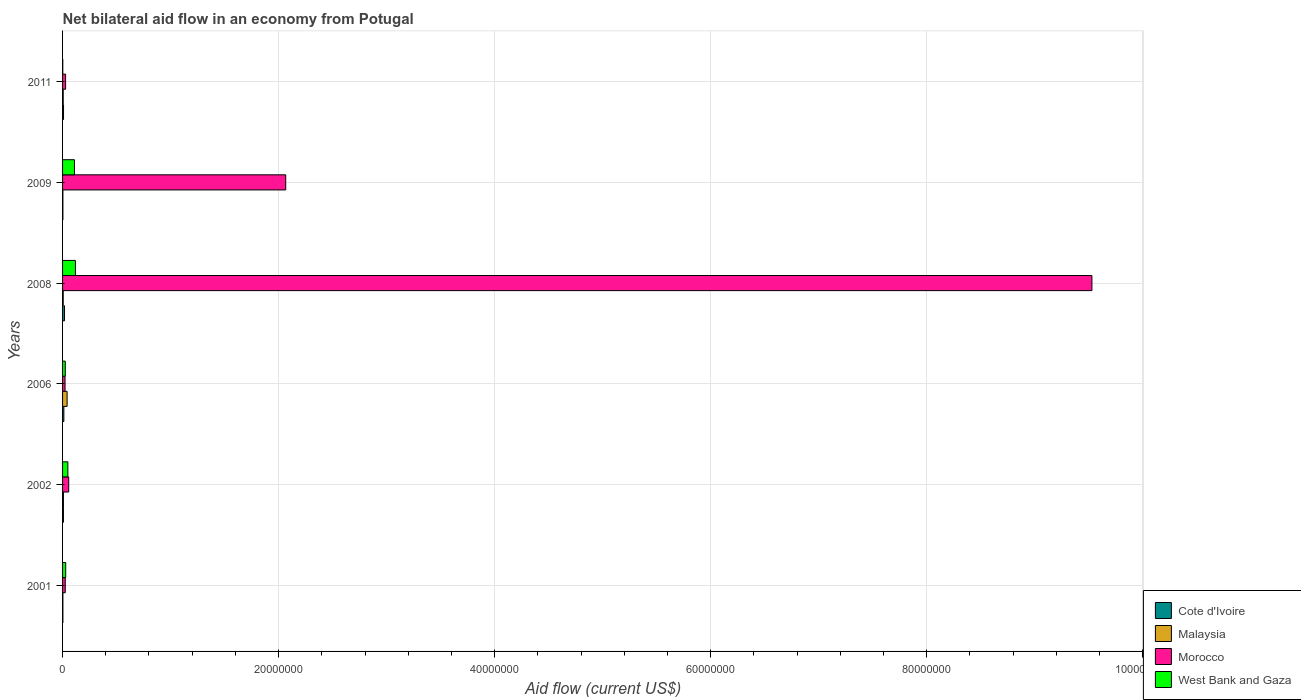How many different coloured bars are there?
Give a very brief answer. 4. Are the number of bars on each tick of the Y-axis equal?
Your answer should be compact. Yes. How many bars are there on the 5th tick from the bottom?
Offer a very short reply. 4. Across all years, what is the maximum net bilateral aid flow in Cote d'Ivoire?
Your response must be concise. 1.80e+05. In which year was the net bilateral aid flow in Malaysia maximum?
Offer a terse response. 2006. What is the total net bilateral aid flow in Morocco in the graph?
Ensure brevity in your answer.  1.17e+08. What is the difference between the net bilateral aid flow in Morocco in 2008 and that in 2009?
Your answer should be very brief. 7.46e+07. What is the difference between the net bilateral aid flow in Cote d'Ivoire in 2006 and the net bilateral aid flow in Morocco in 2009?
Ensure brevity in your answer.  -2.05e+07. What is the average net bilateral aid flow in Cote d'Ivoire per year?
Your response must be concise. 8.83e+04. What is the ratio of the net bilateral aid flow in Cote d'Ivoire in 2002 to that in 2008?
Ensure brevity in your answer.  0.44. Is the difference between the net bilateral aid flow in West Bank and Gaza in 2006 and 2011 greater than the difference between the net bilateral aid flow in Malaysia in 2006 and 2011?
Provide a short and direct response. No. What is the difference between the highest and the second highest net bilateral aid flow in Cote d'Ivoire?
Keep it short and to the point. 6.00e+04. In how many years, is the net bilateral aid flow in Cote d'Ivoire greater than the average net bilateral aid flow in Cote d'Ivoire taken over all years?
Provide a succinct answer. 3. Is it the case that in every year, the sum of the net bilateral aid flow in Morocco and net bilateral aid flow in West Bank and Gaza is greater than the sum of net bilateral aid flow in Cote d'Ivoire and net bilateral aid flow in Malaysia?
Your answer should be very brief. No. What does the 1st bar from the top in 2008 represents?
Offer a terse response. West Bank and Gaza. What does the 4th bar from the bottom in 2011 represents?
Provide a succinct answer. West Bank and Gaza. How many bars are there?
Provide a short and direct response. 24. Are all the bars in the graph horizontal?
Offer a terse response. Yes. What is the difference between two consecutive major ticks on the X-axis?
Offer a very short reply. 2.00e+07. Are the values on the major ticks of X-axis written in scientific E-notation?
Ensure brevity in your answer.  No. How many legend labels are there?
Your answer should be compact. 4. What is the title of the graph?
Offer a very short reply. Net bilateral aid flow in an economy from Potugal. Does "Guyana" appear as one of the legend labels in the graph?
Your answer should be very brief. No. What is the Aid flow (current US$) in Malaysia in 2001?
Give a very brief answer. 3.00e+04. What is the Aid flow (current US$) in West Bank and Gaza in 2001?
Your answer should be very brief. 2.90e+05. What is the Aid flow (current US$) in Morocco in 2002?
Provide a short and direct response. 5.70e+05. What is the Aid flow (current US$) in West Bank and Gaza in 2002?
Your answer should be compact. 4.90e+05. What is the Aid flow (current US$) in Cote d'Ivoire in 2006?
Give a very brief answer. 1.20e+05. What is the Aid flow (current US$) of Malaysia in 2006?
Offer a terse response. 4.20e+05. What is the Aid flow (current US$) of Morocco in 2006?
Give a very brief answer. 2.30e+05. What is the Aid flow (current US$) in Malaysia in 2008?
Make the answer very short. 6.00e+04. What is the Aid flow (current US$) in Morocco in 2008?
Give a very brief answer. 9.53e+07. What is the Aid flow (current US$) of West Bank and Gaza in 2008?
Provide a short and direct response. 1.19e+06. What is the Aid flow (current US$) in Cote d'Ivoire in 2009?
Offer a very short reply. 3.00e+04. What is the Aid flow (current US$) in Malaysia in 2009?
Offer a terse response. 3.00e+04. What is the Aid flow (current US$) of Morocco in 2009?
Your answer should be very brief. 2.07e+07. What is the Aid flow (current US$) in West Bank and Gaza in 2009?
Make the answer very short. 1.10e+06. Across all years, what is the maximum Aid flow (current US$) in Morocco?
Your answer should be very brief. 9.53e+07. Across all years, what is the maximum Aid flow (current US$) in West Bank and Gaza?
Offer a very short reply. 1.19e+06. Across all years, what is the minimum Aid flow (current US$) in Cote d'Ivoire?
Provide a short and direct response. 3.00e+04. Across all years, what is the minimum Aid flow (current US$) of Malaysia?
Provide a succinct answer. 3.00e+04. Across all years, what is the minimum Aid flow (current US$) in Morocco?
Provide a short and direct response. 2.30e+05. Across all years, what is the minimum Aid flow (current US$) of West Bank and Gaza?
Make the answer very short. 2.00e+04. What is the total Aid flow (current US$) of Cote d'Ivoire in the graph?
Keep it short and to the point. 5.30e+05. What is the total Aid flow (current US$) in Malaysia in the graph?
Keep it short and to the point. 6.80e+05. What is the total Aid flow (current US$) in Morocco in the graph?
Your answer should be compact. 1.17e+08. What is the total Aid flow (current US$) in West Bank and Gaza in the graph?
Offer a terse response. 3.34e+06. What is the difference between the Aid flow (current US$) of Cote d'Ivoire in 2001 and that in 2002?
Provide a short and direct response. -5.00e+04. What is the difference between the Aid flow (current US$) of Morocco in 2001 and that in 2002?
Ensure brevity in your answer.  -3.20e+05. What is the difference between the Aid flow (current US$) of Malaysia in 2001 and that in 2006?
Give a very brief answer. -3.90e+05. What is the difference between the Aid flow (current US$) of Morocco in 2001 and that in 2006?
Provide a succinct answer. 2.00e+04. What is the difference between the Aid flow (current US$) in West Bank and Gaza in 2001 and that in 2006?
Ensure brevity in your answer.  4.00e+04. What is the difference between the Aid flow (current US$) of Cote d'Ivoire in 2001 and that in 2008?
Make the answer very short. -1.50e+05. What is the difference between the Aid flow (current US$) of Malaysia in 2001 and that in 2008?
Make the answer very short. -3.00e+04. What is the difference between the Aid flow (current US$) in Morocco in 2001 and that in 2008?
Keep it short and to the point. -9.50e+07. What is the difference between the Aid flow (current US$) of West Bank and Gaza in 2001 and that in 2008?
Your answer should be compact. -9.00e+05. What is the difference between the Aid flow (current US$) of Malaysia in 2001 and that in 2009?
Give a very brief answer. 0. What is the difference between the Aid flow (current US$) of Morocco in 2001 and that in 2009?
Give a very brief answer. -2.04e+07. What is the difference between the Aid flow (current US$) of West Bank and Gaza in 2001 and that in 2009?
Your answer should be very brief. -8.10e+05. What is the difference between the Aid flow (current US$) of Morocco in 2001 and that in 2011?
Provide a succinct answer. -3.00e+04. What is the difference between the Aid flow (current US$) in West Bank and Gaza in 2001 and that in 2011?
Offer a terse response. 2.70e+05. What is the difference between the Aid flow (current US$) in West Bank and Gaza in 2002 and that in 2006?
Make the answer very short. 2.40e+05. What is the difference between the Aid flow (current US$) of Cote d'Ivoire in 2002 and that in 2008?
Your answer should be very brief. -1.00e+05. What is the difference between the Aid flow (current US$) of Malaysia in 2002 and that in 2008?
Offer a terse response. 2.00e+04. What is the difference between the Aid flow (current US$) in Morocco in 2002 and that in 2008?
Offer a terse response. -9.47e+07. What is the difference between the Aid flow (current US$) in West Bank and Gaza in 2002 and that in 2008?
Provide a short and direct response. -7.00e+05. What is the difference between the Aid flow (current US$) of Cote d'Ivoire in 2002 and that in 2009?
Provide a succinct answer. 5.00e+04. What is the difference between the Aid flow (current US$) of Malaysia in 2002 and that in 2009?
Your answer should be very brief. 5.00e+04. What is the difference between the Aid flow (current US$) in Morocco in 2002 and that in 2009?
Keep it short and to the point. -2.01e+07. What is the difference between the Aid flow (current US$) of West Bank and Gaza in 2002 and that in 2009?
Offer a very short reply. -6.10e+05. What is the difference between the Aid flow (current US$) of Morocco in 2002 and that in 2011?
Give a very brief answer. 2.90e+05. What is the difference between the Aid flow (current US$) of Morocco in 2006 and that in 2008?
Your response must be concise. -9.51e+07. What is the difference between the Aid flow (current US$) in West Bank and Gaza in 2006 and that in 2008?
Ensure brevity in your answer.  -9.40e+05. What is the difference between the Aid flow (current US$) in Cote d'Ivoire in 2006 and that in 2009?
Give a very brief answer. 9.00e+04. What is the difference between the Aid flow (current US$) in Malaysia in 2006 and that in 2009?
Provide a succinct answer. 3.90e+05. What is the difference between the Aid flow (current US$) in Morocco in 2006 and that in 2009?
Your answer should be compact. -2.04e+07. What is the difference between the Aid flow (current US$) of West Bank and Gaza in 2006 and that in 2009?
Make the answer very short. -8.50e+05. What is the difference between the Aid flow (current US$) of Morocco in 2006 and that in 2011?
Provide a short and direct response. -5.00e+04. What is the difference between the Aid flow (current US$) in Cote d'Ivoire in 2008 and that in 2009?
Offer a very short reply. 1.50e+05. What is the difference between the Aid flow (current US$) of Malaysia in 2008 and that in 2009?
Your answer should be compact. 3.00e+04. What is the difference between the Aid flow (current US$) in Morocco in 2008 and that in 2009?
Provide a succinct answer. 7.46e+07. What is the difference between the Aid flow (current US$) in West Bank and Gaza in 2008 and that in 2009?
Offer a terse response. 9.00e+04. What is the difference between the Aid flow (current US$) in Malaysia in 2008 and that in 2011?
Provide a short and direct response. 0. What is the difference between the Aid flow (current US$) of Morocco in 2008 and that in 2011?
Your answer should be very brief. 9.50e+07. What is the difference between the Aid flow (current US$) of West Bank and Gaza in 2008 and that in 2011?
Your answer should be compact. 1.17e+06. What is the difference between the Aid flow (current US$) in Morocco in 2009 and that in 2011?
Make the answer very short. 2.04e+07. What is the difference between the Aid flow (current US$) of West Bank and Gaza in 2009 and that in 2011?
Keep it short and to the point. 1.08e+06. What is the difference between the Aid flow (current US$) of Cote d'Ivoire in 2001 and the Aid flow (current US$) of Malaysia in 2002?
Your response must be concise. -5.00e+04. What is the difference between the Aid flow (current US$) in Cote d'Ivoire in 2001 and the Aid flow (current US$) in Morocco in 2002?
Your answer should be very brief. -5.40e+05. What is the difference between the Aid flow (current US$) of Cote d'Ivoire in 2001 and the Aid flow (current US$) of West Bank and Gaza in 2002?
Provide a short and direct response. -4.60e+05. What is the difference between the Aid flow (current US$) in Malaysia in 2001 and the Aid flow (current US$) in Morocco in 2002?
Your response must be concise. -5.40e+05. What is the difference between the Aid flow (current US$) in Malaysia in 2001 and the Aid flow (current US$) in West Bank and Gaza in 2002?
Keep it short and to the point. -4.60e+05. What is the difference between the Aid flow (current US$) of Cote d'Ivoire in 2001 and the Aid flow (current US$) of Malaysia in 2006?
Keep it short and to the point. -3.90e+05. What is the difference between the Aid flow (current US$) in Cote d'Ivoire in 2001 and the Aid flow (current US$) in Morocco in 2006?
Your response must be concise. -2.00e+05. What is the difference between the Aid flow (current US$) in Cote d'Ivoire in 2001 and the Aid flow (current US$) in Morocco in 2008?
Keep it short and to the point. -9.53e+07. What is the difference between the Aid flow (current US$) of Cote d'Ivoire in 2001 and the Aid flow (current US$) of West Bank and Gaza in 2008?
Give a very brief answer. -1.16e+06. What is the difference between the Aid flow (current US$) of Malaysia in 2001 and the Aid flow (current US$) of Morocco in 2008?
Make the answer very short. -9.53e+07. What is the difference between the Aid flow (current US$) in Malaysia in 2001 and the Aid flow (current US$) in West Bank and Gaza in 2008?
Give a very brief answer. -1.16e+06. What is the difference between the Aid flow (current US$) of Morocco in 2001 and the Aid flow (current US$) of West Bank and Gaza in 2008?
Make the answer very short. -9.40e+05. What is the difference between the Aid flow (current US$) in Cote d'Ivoire in 2001 and the Aid flow (current US$) in Malaysia in 2009?
Keep it short and to the point. 0. What is the difference between the Aid flow (current US$) in Cote d'Ivoire in 2001 and the Aid flow (current US$) in Morocco in 2009?
Your response must be concise. -2.06e+07. What is the difference between the Aid flow (current US$) of Cote d'Ivoire in 2001 and the Aid flow (current US$) of West Bank and Gaza in 2009?
Offer a very short reply. -1.07e+06. What is the difference between the Aid flow (current US$) in Malaysia in 2001 and the Aid flow (current US$) in Morocco in 2009?
Ensure brevity in your answer.  -2.06e+07. What is the difference between the Aid flow (current US$) of Malaysia in 2001 and the Aid flow (current US$) of West Bank and Gaza in 2009?
Offer a very short reply. -1.07e+06. What is the difference between the Aid flow (current US$) of Morocco in 2001 and the Aid flow (current US$) of West Bank and Gaza in 2009?
Your response must be concise. -8.50e+05. What is the difference between the Aid flow (current US$) of Cote d'Ivoire in 2001 and the Aid flow (current US$) of Malaysia in 2011?
Your answer should be compact. -3.00e+04. What is the difference between the Aid flow (current US$) in Malaysia in 2001 and the Aid flow (current US$) in Morocco in 2011?
Provide a short and direct response. -2.50e+05. What is the difference between the Aid flow (current US$) in Malaysia in 2001 and the Aid flow (current US$) in West Bank and Gaza in 2011?
Ensure brevity in your answer.  10000. What is the difference between the Aid flow (current US$) of Cote d'Ivoire in 2002 and the Aid flow (current US$) of Morocco in 2006?
Offer a very short reply. -1.50e+05. What is the difference between the Aid flow (current US$) of Morocco in 2002 and the Aid flow (current US$) of West Bank and Gaza in 2006?
Give a very brief answer. 3.20e+05. What is the difference between the Aid flow (current US$) of Cote d'Ivoire in 2002 and the Aid flow (current US$) of Malaysia in 2008?
Give a very brief answer. 2.00e+04. What is the difference between the Aid flow (current US$) of Cote d'Ivoire in 2002 and the Aid flow (current US$) of Morocco in 2008?
Give a very brief answer. -9.52e+07. What is the difference between the Aid flow (current US$) of Cote d'Ivoire in 2002 and the Aid flow (current US$) of West Bank and Gaza in 2008?
Offer a terse response. -1.11e+06. What is the difference between the Aid flow (current US$) of Malaysia in 2002 and the Aid flow (current US$) of Morocco in 2008?
Provide a short and direct response. -9.52e+07. What is the difference between the Aid flow (current US$) of Malaysia in 2002 and the Aid flow (current US$) of West Bank and Gaza in 2008?
Provide a short and direct response. -1.11e+06. What is the difference between the Aid flow (current US$) of Morocco in 2002 and the Aid flow (current US$) of West Bank and Gaza in 2008?
Offer a very short reply. -6.20e+05. What is the difference between the Aid flow (current US$) of Cote d'Ivoire in 2002 and the Aid flow (current US$) of Malaysia in 2009?
Make the answer very short. 5.00e+04. What is the difference between the Aid flow (current US$) of Cote d'Ivoire in 2002 and the Aid flow (current US$) of Morocco in 2009?
Ensure brevity in your answer.  -2.06e+07. What is the difference between the Aid flow (current US$) in Cote d'Ivoire in 2002 and the Aid flow (current US$) in West Bank and Gaza in 2009?
Keep it short and to the point. -1.02e+06. What is the difference between the Aid flow (current US$) in Malaysia in 2002 and the Aid flow (current US$) in Morocco in 2009?
Your answer should be very brief. -2.06e+07. What is the difference between the Aid flow (current US$) in Malaysia in 2002 and the Aid flow (current US$) in West Bank and Gaza in 2009?
Your response must be concise. -1.02e+06. What is the difference between the Aid flow (current US$) of Morocco in 2002 and the Aid flow (current US$) of West Bank and Gaza in 2009?
Offer a terse response. -5.30e+05. What is the difference between the Aid flow (current US$) of Cote d'Ivoire in 2006 and the Aid flow (current US$) of Malaysia in 2008?
Give a very brief answer. 6.00e+04. What is the difference between the Aid flow (current US$) of Cote d'Ivoire in 2006 and the Aid flow (current US$) of Morocco in 2008?
Offer a very short reply. -9.52e+07. What is the difference between the Aid flow (current US$) of Cote d'Ivoire in 2006 and the Aid flow (current US$) of West Bank and Gaza in 2008?
Keep it short and to the point. -1.07e+06. What is the difference between the Aid flow (current US$) in Malaysia in 2006 and the Aid flow (current US$) in Morocco in 2008?
Offer a terse response. -9.49e+07. What is the difference between the Aid flow (current US$) in Malaysia in 2006 and the Aid flow (current US$) in West Bank and Gaza in 2008?
Make the answer very short. -7.70e+05. What is the difference between the Aid flow (current US$) of Morocco in 2006 and the Aid flow (current US$) of West Bank and Gaza in 2008?
Your response must be concise. -9.60e+05. What is the difference between the Aid flow (current US$) in Cote d'Ivoire in 2006 and the Aid flow (current US$) in Morocco in 2009?
Provide a succinct answer. -2.05e+07. What is the difference between the Aid flow (current US$) in Cote d'Ivoire in 2006 and the Aid flow (current US$) in West Bank and Gaza in 2009?
Give a very brief answer. -9.80e+05. What is the difference between the Aid flow (current US$) in Malaysia in 2006 and the Aid flow (current US$) in Morocco in 2009?
Offer a very short reply. -2.02e+07. What is the difference between the Aid flow (current US$) in Malaysia in 2006 and the Aid flow (current US$) in West Bank and Gaza in 2009?
Your response must be concise. -6.80e+05. What is the difference between the Aid flow (current US$) in Morocco in 2006 and the Aid flow (current US$) in West Bank and Gaza in 2009?
Keep it short and to the point. -8.70e+05. What is the difference between the Aid flow (current US$) of Cote d'Ivoire in 2006 and the Aid flow (current US$) of Malaysia in 2011?
Keep it short and to the point. 6.00e+04. What is the difference between the Aid flow (current US$) in Cote d'Ivoire in 2006 and the Aid flow (current US$) in Morocco in 2011?
Your answer should be very brief. -1.60e+05. What is the difference between the Aid flow (current US$) in Cote d'Ivoire in 2008 and the Aid flow (current US$) in Morocco in 2009?
Offer a very short reply. -2.05e+07. What is the difference between the Aid flow (current US$) of Cote d'Ivoire in 2008 and the Aid flow (current US$) of West Bank and Gaza in 2009?
Keep it short and to the point. -9.20e+05. What is the difference between the Aid flow (current US$) of Malaysia in 2008 and the Aid flow (current US$) of Morocco in 2009?
Provide a succinct answer. -2.06e+07. What is the difference between the Aid flow (current US$) of Malaysia in 2008 and the Aid flow (current US$) of West Bank and Gaza in 2009?
Make the answer very short. -1.04e+06. What is the difference between the Aid flow (current US$) of Morocco in 2008 and the Aid flow (current US$) of West Bank and Gaza in 2009?
Your answer should be compact. 9.42e+07. What is the difference between the Aid flow (current US$) of Cote d'Ivoire in 2008 and the Aid flow (current US$) of Malaysia in 2011?
Keep it short and to the point. 1.20e+05. What is the difference between the Aid flow (current US$) of Cote d'Ivoire in 2008 and the Aid flow (current US$) of West Bank and Gaza in 2011?
Provide a short and direct response. 1.60e+05. What is the difference between the Aid flow (current US$) in Malaysia in 2008 and the Aid flow (current US$) in Morocco in 2011?
Offer a very short reply. -2.20e+05. What is the difference between the Aid flow (current US$) in Morocco in 2008 and the Aid flow (current US$) in West Bank and Gaza in 2011?
Provide a succinct answer. 9.53e+07. What is the difference between the Aid flow (current US$) in Cote d'Ivoire in 2009 and the Aid flow (current US$) in Morocco in 2011?
Your answer should be very brief. -2.50e+05. What is the difference between the Aid flow (current US$) of Cote d'Ivoire in 2009 and the Aid flow (current US$) of West Bank and Gaza in 2011?
Offer a terse response. 10000. What is the difference between the Aid flow (current US$) in Morocco in 2009 and the Aid flow (current US$) in West Bank and Gaza in 2011?
Your answer should be compact. 2.06e+07. What is the average Aid flow (current US$) of Cote d'Ivoire per year?
Ensure brevity in your answer.  8.83e+04. What is the average Aid flow (current US$) of Malaysia per year?
Your answer should be very brief. 1.13e+05. What is the average Aid flow (current US$) in Morocco per year?
Offer a very short reply. 1.95e+07. What is the average Aid flow (current US$) of West Bank and Gaza per year?
Provide a succinct answer. 5.57e+05. In the year 2001, what is the difference between the Aid flow (current US$) of Cote d'Ivoire and Aid flow (current US$) of West Bank and Gaza?
Offer a terse response. -2.60e+05. In the year 2001, what is the difference between the Aid flow (current US$) in Malaysia and Aid flow (current US$) in Morocco?
Your response must be concise. -2.20e+05. In the year 2001, what is the difference between the Aid flow (current US$) of Morocco and Aid flow (current US$) of West Bank and Gaza?
Provide a succinct answer. -4.00e+04. In the year 2002, what is the difference between the Aid flow (current US$) in Cote d'Ivoire and Aid flow (current US$) in Malaysia?
Make the answer very short. 0. In the year 2002, what is the difference between the Aid flow (current US$) in Cote d'Ivoire and Aid flow (current US$) in Morocco?
Offer a very short reply. -4.90e+05. In the year 2002, what is the difference between the Aid flow (current US$) of Cote d'Ivoire and Aid flow (current US$) of West Bank and Gaza?
Your answer should be compact. -4.10e+05. In the year 2002, what is the difference between the Aid flow (current US$) of Malaysia and Aid flow (current US$) of Morocco?
Your answer should be compact. -4.90e+05. In the year 2002, what is the difference between the Aid flow (current US$) of Malaysia and Aid flow (current US$) of West Bank and Gaza?
Offer a very short reply. -4.10e+05. In the year 2006, what is the difference between the Aid flow (current US$) in Cote d'Ivoire and Aid flow (current US$) in Morocco?
Keep it short and to the point. -1.10e+05. In the year 2006, what is the difference between the Aid flow (current US$) of Cote d'Ivoire and Aid flow (current US$) of West Bank and Gaza?
Make the answer very short. -1.30e+05. In the year 2006, what is the difference between the Aid flow (current US$) of Malaysia and Aid flow (current US$) of West Bank and Gaza?
Keep it short and to the point. 1.70e+05. In the year 2006, what is the difference between the Aid flow (current US$) of Morocco and Aid flow (current US$) of West Bank and Gaza?
Make the answer very short. -2.00e+04. In the year 2008, what is the difference between the Aid flow (current US$) of Cote d'Ivoire and Aid flow (current US$) of Morocco?
Provide a short and direct response. -9.51e+07. In the year 2008, what is the difference between the Aid flow (current US$) of Cote d'Ivoire and Aid flow (current US$) of West Bank and Gaza?
Offer a very short reply. -1.01e+06. In the year 2008, what is the difference between the Aid flow (current US$) in Malaysia and Aid flow (current US$) in Morocco?
Make the answer very short. -9.52e+07. In the year 2008, what is the difference between the Aid flow (current US$) in Malaysia and Aid flow (current US$) in West Bank and Gaza?
Provide a succinct answer. -1.13e+06. In the year 2008, what is the difference between the Aid flow (current US$) of Morocco and Aid flow (current US$) of West Bank and Gaza?
Ensure brevity in your answer.  9.41e+07. In the year 2009, what is the difference between the Aid flow (current US$) of Cote d'Ivoire and Aid flow (current US$) of Malaysia?
Provide a succinct answer. 0. In the year 2009, what is the difference between the Aid flow (current US$) in Cote d'Ivoire and Aid flow (current US$) in Morocco?
Offer a terse response. -2.06e+07. In the year 2009, what is the difference between the Aid flow (current US$) of Cote d'Ivoire and Aid flow (current US$) of West Bank and Gaza?
Give a very brief answer. -1.07e+06. In the year 2009, what is the difference between the Aid flow (current US$) in Malaysia and Aid flow (current US$) in Morocco?
Your answer should be compact. -2.06e+07. In the year 2009, what is the difference between the Aid flow (current US$) in Malaysia and Aid flow (current US$) in West Bank and Gaza?
Provide a short and direct response. -1.07e+06. In the year 2009, what is the difference between the Aid flow (current US$) in Morocco and Aid flow (current US$) in West Bank and Gaza?
Ensure brevity in your answer.  1.96e+07. In the year 2011, what is the difference between the Aid flow (current US$) of Cote d'Ivoire and Aid flow (current US$) of Malaysia?
Provide a succinct answer. 3.00e+04. In the year 2011, what is the difference between the Aid flow (current US$) in Cote d'Ivoire and Aid flow (current US$) in West Bank and Gaza?
Provide a succinct answer. 7.00e+04. In the year 2011, what is the difference between the Aid flow (current US$) in Malaysia and Aid flow (current US$) in Morocco?
Your response must be concise. -2.20e+05. In the year 2011, what is the difference between the Aid flow (current US$) of Malaysia and Aid flow (current US$) of West Bank and Gaza?
Make the answer very short. 4.00e+04. In the year 2011, what is the difference between the Aid flow (current US$) in Morocco and Aid flow (current US$) in West Bank and Gaza?
Provide a succinct answer. 2.60e+05. What is the ratio of the Aid flow (current US$) in Cote d'Ivoire in 2001 to that in 2002?
Offer a terse response. 0.38. What is the ratio of the Aid flow (current US$) in Morocco in 2001 to that in 2002?
Keep it short and to the point. 0.44. What is the ratio of the Aid flow (current US$) in West Bank and Gaza in 2001 to that in 2002?
Provide a short and direct response. 0.59. What is the ratio of the Aid flow (current US$) in Cote d'Ivoire in 2001 to that in 2006?
Give a very brief answer. 0.25. What is the ratio of the Aid flow (current US$) of Malaysia in 2001 to that in 2006?
Make the answer very short. 0.07. What is the ratio of the Aid flow (current US$) in Morocco in 2001 to that in 2006?
Ensure brevity in your answer.  1.09. What is the ratio of the Aid flow (current US$) in West Bank and Gaza in 2001 to that in 2006?
Ensure brevity in your answer.  1.16. What is the ratio of the Aid flow (current US$) in Cote d'Ivoire in 2001 to that in 2008?
Provide a short and direct response. 0.17. What is the ratio of the Aid flow (current US$) of Malaysia in 2001 to that in 2008?
Provide a succinct answer. 0.5. What is the ratio of the Aid flow (current US$) in Morocco in 2001 to that in 2008?
Your response must be concise. 0. What is the ratio of the Aid flow (current US$) in West Bank and Gaza in 2001 to that in 2008?
Provide a succinct answer. 0.24. What is the ratio of the Aid flow (current US$) of Cote d'Ivoire in 2001 to that in 2009?
Your answer should be very brief. 1. What is the ratio of the Aid flow (current US$) in Malaysia in 2001 to that in 2009?
Your answer should be very brief. 1. What is the ratio of the Aid flow (current US$) of Morocco in 2001 to that in 2009?
Provide a succinct answer. 0.01. What is the ratio of the Aid flow (current US$) in West Bank and Gaza in 2001 to that in 2009?
Your answer should be very brief. 0.26. What is the ratio of the Aid flow (current US$) of Malaysia in 2001 to that in 2011?
Provide a short and direct response. 0.5. What is the ratio of the Aid flow (current US$) of Morocco in 2001 to that in 2011?
Keep it short and to the point. 0.89. What is the ratio of the Aid flow (current US$) of Cote d'Ivoire in 2002 to that in 2006?
Provide a succinct answer. 0.67. What is the ratio of the Aid flow (current US$) of Malaysia in 2002 to that in 2006?
Give a very brief answer. 0.19. What is the ratio of the Aid flow (current US$) of Morocco in 2002 to that in 2006?
Provide a short and direct response. 2.48. What is the ratio of the Aid flow (current US$) of West Bank and Gaza in 2002 to that in 2006?
Give a very brief answer. 1.96. What is the ratio of the Aid flow (current US$) in Cote d'Ivoire in 2002 to that in 2008?
Keep it short and to the point. 0.44. What is the ratio of the Aid flow (current US$) of Morocco in 2002 to that in 2008?
Offer a terse response. 0.01. What is the ratio of the Aid flow (current US$) in West Bank and Gaza in 2002 to that in 2008?
Give a very brief answer. 0.41. What is the ratio of the Aid flow (current US$) in Cote d'Ivoire in 2002 to that in 2009?
Your response must be concise. 2.67. What is the ratio of the Aid flow (current US$) of Malaysia in 2002 to that in 2009?
Your response must be concise. 2.67. What is the ratio of the Aid flow (current US$) of Morocco in 2002 to that in 2009?
Offer a very short reply. 0.03. What is the ratio of the Aid flow (current US$) in West Bank and Gaza in 2002 to that in 2009?
Ensure brevity in your answer.  0.45. What is the ratio of the Aid flow (current US$) of Cote d'Ivoire in 2002 to that in 2011?
Make the answer very short. 0.89. What is the ratio of the Aid flow (current US$) of Malaysia in 2002 to that in 2011?
Give a very brief answer. 1.33. What is the ratio of the Aid flow (current US$) in Morocco in 2002 to that in 2011?
Offer a very short reply. 2.04. What is the ratio of the Aid flow (current US$) of West Bank and Gaza in 2002 to that in 2011?
Make the answer very short. 24.5. What is the ratio of the Aid flow (current US$) of Cote d'Ivoire in 2006 to that in 2008?
Your response must be concise. 0.67. What is the ratio of the Aid flow (current US$) in Malaysia in 2006 to that in 2008?
Offer a very short reply. 7. What is the ratio of the Aid flow (current US$) of Morocco in 2006 to that in 2008?
Make the answer very short. 0. What is the ratio of the Aid flow (current US$) in West Bank and Gaza in 2006 to that in 2008?
Keep it short and to the point. 0.21. What is the ratio of the Aid flow (current US$) of Cote d'Ivoire in 2006 to that in 2009?
Offer a terse response. 4. What is the ratio of the Aid flow (current US$) of Malaysia in 2006 to that in 2009?
Offer a terse response. 14. What is the ratio of the Aid flow (current US$) of Morocco in 2006 to that in 2009?
Your answer should be compact. 0.01. What is the ratio of the Aid flow (current US$) of West Bank and Gaza in 2006 to that in 2009?
Your response must be concise. 0.23. What is the ratio of the Aid flow (current US$) of Morocco in 2006 to that in 2011?
Provide a succinct answer. 0.82. What is the ratio of the Aid flow (current US$) of West Bank and Gaza in 2006 to that in 2011?
Your response must be concise. 12.5. What is the ratio of the Aid flow (current US$) of Cote d'Ivoire in 2008 to that in 2009?
Your response must be concise. 6. What is the ratio of the Aid flow (current US$) of Malaysia in 2008 to that in 2009?
Keep it short and to the point. 2. What is the ratio of the Aid flow (current US$) in Morocco in 2008 to that in 2009?
Provide a succinct answer. 4.61. What is the ratio of the Aid flow (current US$) in West Bank and Gaza in 2008 to that in 2009?
Your response must be concise. 1.08. What is the ratio of the Aid flow (current US$) in Malaysia in 2008 to that in 2011?
Give a very brief answer. 1. What is the ratio of the Aid flow (current US$) in Morocco in 2008 to that in 2011?
Provide a succinct answer. 340.36. What is the ratio of the Aid flow (current US$) in West Bank and Gaza in 2008 to that in 2011?
Offer a terse response. 59.5. What is the ratio of the Aid flow (current US$) in Malaysia in 2009 to that in 2011?
Provide a short and direct response. 0.5. What is the ratio of the Aid flow (current US$) in Morocco in 2009 to that in 2011?
Offer a terse response. 73.79. What is the difference between the highest and the second highest Aid flow (current US$) of Malaysia?
Provide a succinct answer. 3.40e+05. What is the difference between the highest and the second highest Aid flow (current US$) of Morocco?
Your answer should be very brief. 7.46e+07. What is the difference between the highest and the lowest Aid flow (current US$) of Cote d'Ivoire?
Give a very brief answer. 1.50e+05. What is the difference between the highest and the lowest Aid flow (current US$) of Morocco?
Offer a very short reply. 9.51e+07. What is the difference between the highest and the lowest Aid flow (current US$) of West Bank and Gaza?
Keep it short and to the point. 1.17e+06. 